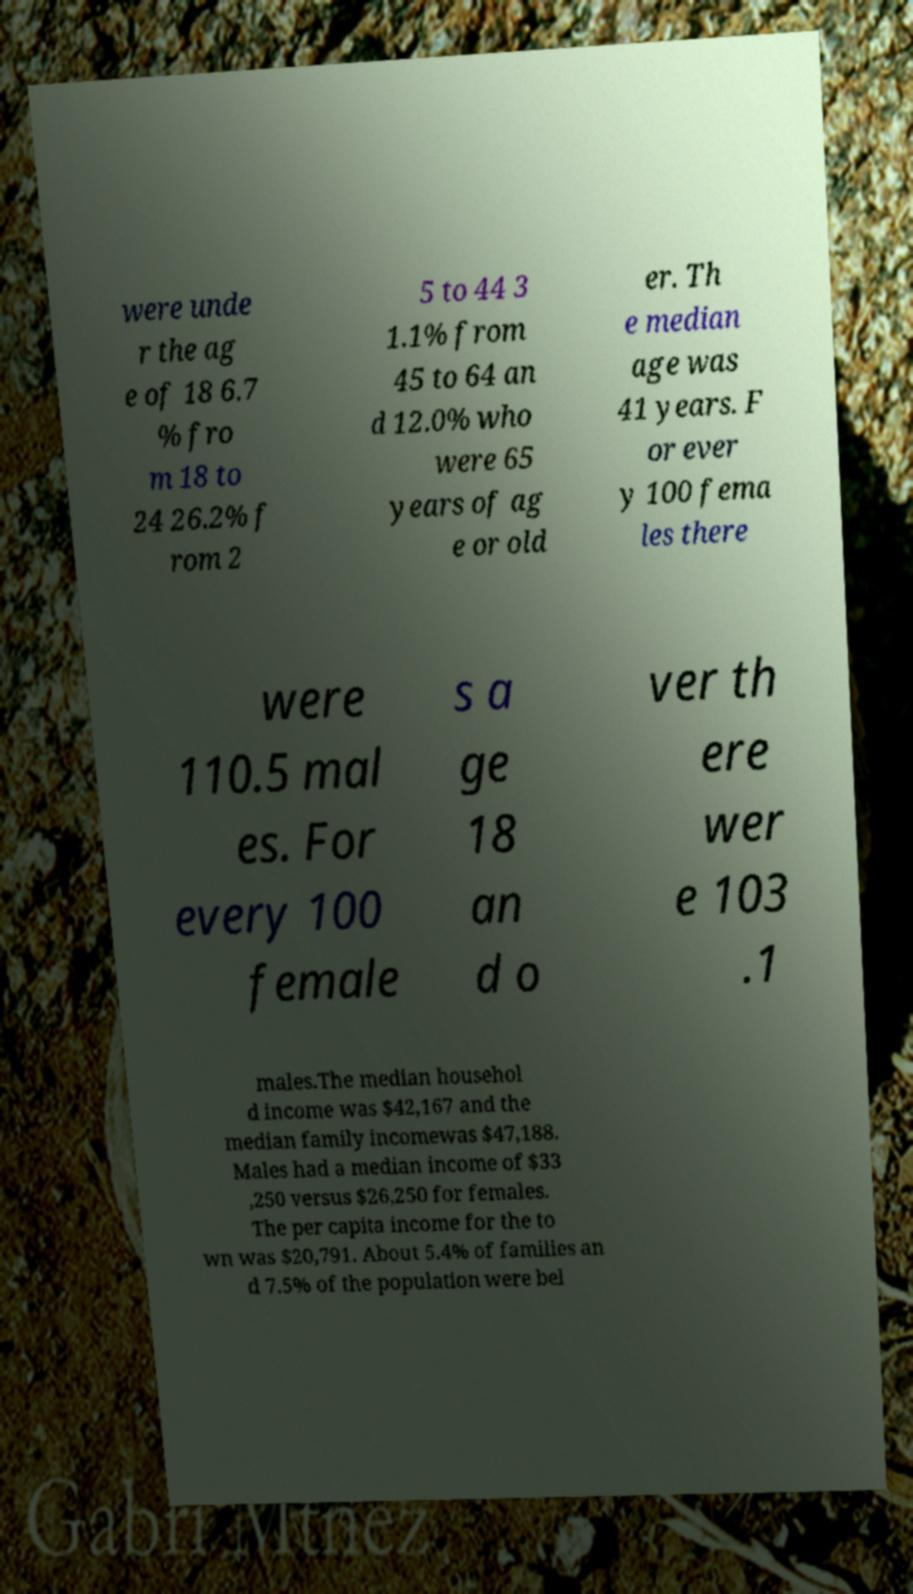What messages or text are displayed in this image? I need them in a readable, typed format. were unde r the ag e of 18 6.7 % fro m 18 to 24 26.2% f rom 2 5 to 44 3 1.1% from 45 to 64 an d 12.0% who were 65 years of ag e or old er. Th e median age was 41 years. F or ever y 100 fema les there were 110.5 mal es. For every 100 female s a ge 18 an d o ver th ere wer e 103 .1 males.The median househol d income was $42,167 and the median family incomewas $47,188. Males had a median income of $33 ,250 versus $26,250 for females. The per capita income for the to wn was $20,791. About 5.4% of families an d 7.5% of the population were bel 